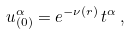<formula> <loc_0><loc_0><loc_500><loc_500>u _ { ( 0 ) } ^ { \alpha } = e ^ { - \nu ( r ) } \, t ^ { \alpha } \, ,</formula> 